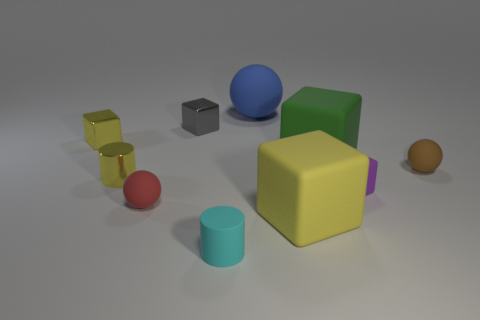Subtract all gray cubes. How many cubes are left? 4 Subtract all small purple matte cubes. How many cubes are left? 4 Subtract all cyan cubes. Subtract all brown cylinders. How many cubes are left? 5 Subtract all cylinders. How many objects are left? 8 Subtract all small metallic cylinders. Subtract all shiny objects. How many objects are left? 6 Add 6 tiny red rubber objects. How many tiny red rubber objects are left? 7 Add 2 gray metal things. How many gray metal things exist? 3 Subtract 0 cyan blocks. How many objects are left? 10 